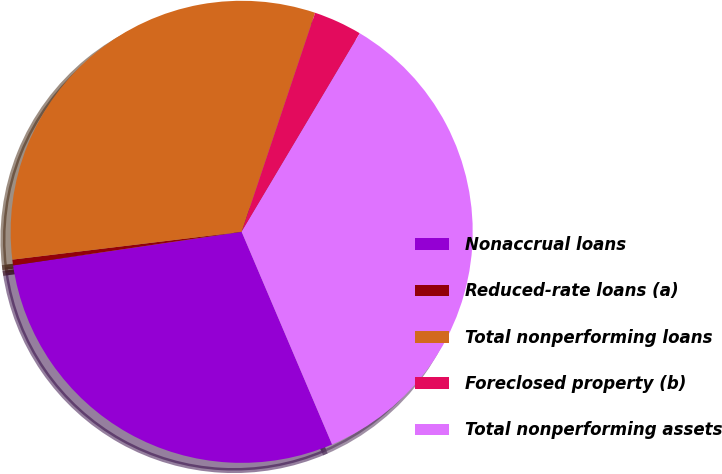Convert chart. <chart><loc_0><loc_0><loc_500><loc_500><pie_chart><fcel>Nonaccrual loans<fcel>Reduced-rate loans (a)<fcel>Total nonperforming loans<fcel>Foreclosed property (b)<fcel>Total nonperforming assets<nl><fcel>29.08%<fcel>0.4%<fcel>32.07%<fcel>3.39%<fcel>35.06%<nl></chart> 